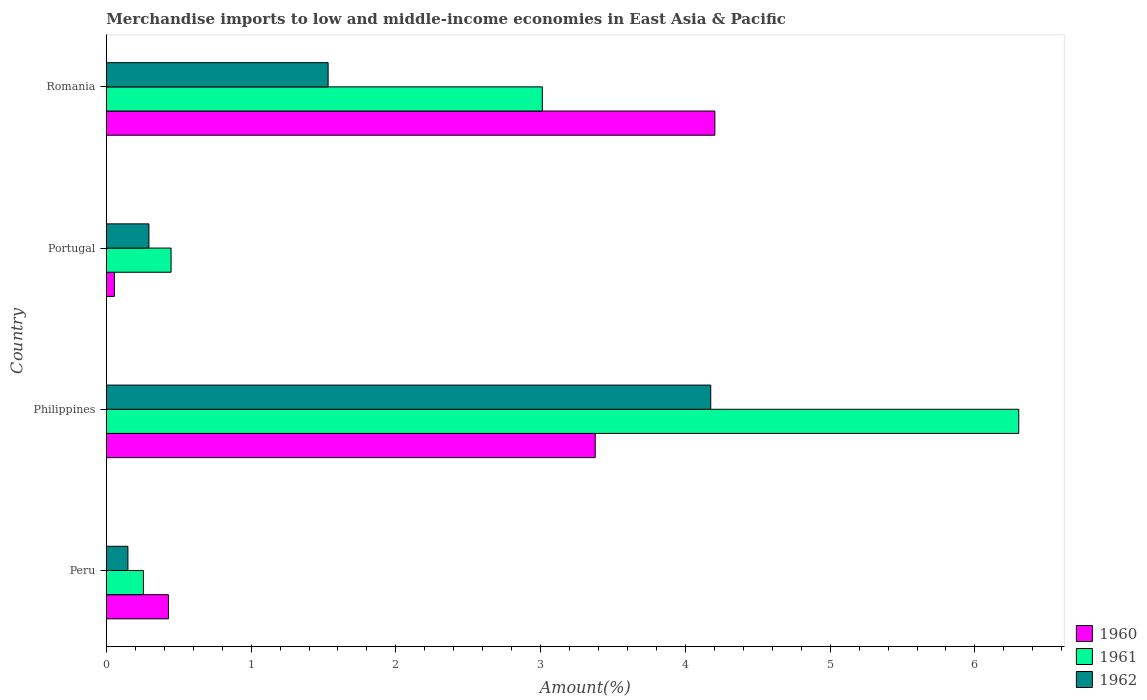Are the number of bars per tick equal to the number of legend labels?
Your response must be concise. Yes. How many bars are there on the 3rd tick from the top?
Ensure brevity in your answer.  3. What is the percentage of amount earned from merchandise imports in 1962 in Romania?
Your response must be concise. 1.53. Across all countries, what is the maximum percentage of amount earned from merchandise imports in 1962?
Provide a succinct answer. 4.18. Across all countries, what is the minimum percentage of amount earned from merchandise imports in 1960?
Your answer should be very brief. 0.06. In which country was the percentage of amount earned from merchandise imports in 1960 maximum?
Provide a short and direct response. Romania. In which country was the percentage of amount earned from merchandise imports in 1962 minimum?
Keep it short and to the point. Peru. What is the total percentage of amount earned from merchandise imports in 1960 in the graph?
Make the answer very short. 8.07. What is the difference between the percentage of amount earned from merchandise imports in 1961 in Peru and that in Romania?
Provide a succinct answer. -2.76. What is the difference between the percentage of amount earned from merchandise imports in 1960 in Peru and the percentage of amount earned from merchandise imports in 1962 in Romania?
Your answer should be compact. -1.1. What is the average percentage of amount earned from merchandise imports in 1960 per country?
Ensure brevity in your answer.  2.02. What is the difference between the percentage of amount earned from merchandise imports in 1961 and percentage of amount earned from merchandise imports in 1962 in Romania?
Offer a terse response. 1.48. In how many countries, is the percentage of amount earned from merchandise imports in 1962 greater than 2.6 %?
Provide a short and direct response. 1. What is the ratio of the percentage of amount earned from merchandise imports in 1961 in Peru to that in Portugal?
Offer a terse response. 0.57. Is the percentage of amount earned from merchandise imports in 1960 in Peru less than that in Portugal?
Your response must be concise. No. Is the difference between the percentage of amount earned from merchandise imports in 1961 in Peru and Portugal greater than the difference between the percentage of amount earned from merchandise imports in 1962 in Peru and Portugal?
Keep it short and to the point. No. What is the difference between the highest and the second highest percentage of amount earned from merchandise imports in 1960?
Ensure brevity in your answer.  0.83. What is the difference between the highest and the lowest percentage of amount earned from merchandise imports in 1960?
Keep it short and to the point. 4.15. In how many countries, is the percentage of amount earned from merchandise imports in 1961 greater than the average percentage of amount earned from merchandise imports in 1961 taken over all countries?
Provide a succinct answer. 2. Are all the bars in the graph horizontal?
Offer a very short reply. Yes. What is the difference between two consecutive major ticks on the X-axis?
Ensure brevity in your answer.  1. Are the values on the major ticks of X-axis written in scientific E-notation?
Your answer should be very brief. No. Does the graph contain any zero values?
Offer a very short reply. No. How many legend labels are there?
Your answer should be compact. 3. What is the title of the graph?
Your answer should be compact. Merchandise imports to low and middle-income economies in East Asia & Pacific. What is the label or title of the X-axis?
Your answer should be compact. Amount(%). What is the Amount(%) in 1960 in Peru?
Your response must be concise. 0.43. What is the Amount(%) of 1961 in Peru?
Give a very brief answer. 0.26. What is the Amount(%) in 1962 in Peru?
Your response must be concise. 0.15. What is the Amount(%) of 1960 in Philippines?
Your response must be concise. 3.38. What is the Amount(%) in 1961 in Philippines?
Offer a very short reply. 6.3. What is the Amount(%) in 1962 in Philippines?
Give a very brief answer. 4.18. What is the Amount(%) of 1960 in Portugal?
Keep it short and to the point. 0.06. What is the Amount(%) of 1961 in Portugal?
Provide a succinct answer. 0.45. What is the Amount(%) of 1962 in Portugal?
Your answer should be compact. 0.29. What is the Amount(%) in 1960 in Romania?
Offer a very short reply. 4.2. What is the Amount(%) in 1961 in Romania?
Offer a terse response. 3.01. What is the Amount(%) in 1962 in Romania?
Your answer should be very brief. 1.53. Across all countries, what is the maximum Amount(%) of 1960?
Your answer should be compact. 4.2. Across all countries, what is the maximum Amount(%) in 1961?
Offer a very short reply. 6.3. Across all countries, what is the maximum Amount(%) of 1962?
Make the answer very short. 4.18. Across all countries, what is the minimum Amount(%) of 1960?
Your response must be concise. 0.06. Across all countries, what is the minimum Amount(%) of 1961?
Offer a terse response. 0.26. Across all countries, what is the minimum Amount(%) in 1962?
Give a very brief answer. 0.15. What is the total Amount(%) of 1960 in the graph?
Provide a short and direct response. 8.07. What is the total Amount(%) of 1961 in the graph?
Your answer should be very brief. 10.02. What is the total Amount(%) in 1962 in the graph?
Offer a terse response. 6.15. What is the difference between the Amount(%) of 1960 in Peru and that in Philippines?
Your answer should be very brief. -2.95. What is the difference between the Amount(%) of 1961 in Peru and that in Philippines?
Your answer should be very brief. -6.05. What is the difference between the Amount(%) in 1962 in Peru and that in Philippines?
Give a very brief answer. -4.03. What is the difference between the Amount(%) in 1960 in Peru and that in Portugal?
Your response must be concise. 0.37. What is the difference between the Amount(%) in 1961 in Peru and that in Portugal?
Your answer should be compact. -0.19. What is the difference between the Amount(%) in 1962 in Peru and that in Portugal?
Provide a short and direct response. -0.14. What is the difference between the Amount(%) of 1960 in Peru and that in Romania?
Make the answer very short. -3.77. What is the difference between the Amount(%) in 1961 in Peru and that in Romania?
Your response must be concise. -2.76. What is the difference between the Amount(%) of 1962 in Peru and that in Romania?
Provide a succinct answer. -1.38. What is the difference between the Amount(%) of 1960 in Philippines and that in Portugal?
Your response must be concise. 3.32. What is the difference between the Amount(%) of 1961 in Philippines and that in Portugal?
Provide a succinct answer. 5.86. What is the difference between the Amount(%) of 1962 in Philippines and that in Portugal?
Give a very brief answer. 3.88. What is the difference between the Amount(%) in 1960 in Philippines and that in Romania?
Your answer should be very brief. -0.83. What is the difference between the Amount(%) in 1961 in Philippines and that in Romania?
Offer a very short reply. 3.29. What is the difference between the Amount(%) in 1962 in Philippines and that in Romania?
Offer a very short reply. 2.64. What is the difference between the Amount(%) in 1960 in Portugal and that in Romania?
Ensure brevity in your answer.  -4.15. What is the difference between the Amount(%) in 1961 in Portugal and that in Romania?
Give a very brief answer. -2.56. What is the difference between the Amount(%) in 1962 in Portugal and that in Romania?
Make the answer very short. -1.24. What is the difference between the Amount(%) in 1960 in Peru and the Amount(%) in 1961 in Philippines?
Offer a terse response. -5.87. What is the difference between the Amount(%) in 1960 in Peru and the Amount(%) in 1962 in Philippines?
Make the answer very short. -3.75. What is the difference between the Amount(%) in 1961 in Peru and the Amount(%) in 1962 in Philippines?
Your answer should be very brief. -3.92. What is the difference between the Amount(%) in 1960 in Peru and the Amount(%) in 1961 in Portugal?
Offer a terse response. -0.02. What is the difference between the Amount(%) in 1960 in Peru and the Amount(%) in 1962 in Portugal?
Offer a terse response. 0.14. What is the difference between the Amount(%) in 1961 in Peru and the Amount(%) in 1962 in Portugal?
Offer a terse response. -0.04. What is the difference between the Amount(%) in 1960 in Peru and the Amount(%) in 1961 in Romania?
Your answer should be compact. -2.58. What is the difference between the Amount(%) in 1960 in Peru and the Amount(%) in 1962 in Romania?
Your answer should be very brief. -1.1. What is the difference between the Amount(%) of 1961 in Peru and the Amount(%) of 1962 in Romania?
Ensure brevity in your answer.  -1.28. What is the difference between the Amount(%) of 1960 in Philippines and the Amount(%) of 1961 in Portugal?
Ensure brevity in your answer.  2.93. What is the difference between the Amount(%) in 1960 in Philippines and the Amount(%) in 1962 in Portugal?
Provide a short and direct response. 3.08. What is the difference between the Amount(%) in 1961 in Philippines and the Amount(%) in 1962 in Portugal?
Offer a very short reply. 6.01. What is the difference between the Amount(%) in 1960 in Philippines and the Amount(%) in 1961 in Romania?
Provide a short and direct response. 0.37. What is the difference between the Amount(%) in 1960 in Philippines and the Amount(%) in 1962 in Romania?
Keep it short and to the point. 1.85. What is the difference between the Amount(%) in 1961 in Philippines and the Amount(%) in 1962 in Romania?
Provide a short and direct response. 4.77. What is the difference between the Amount(%) of 1960 in Portugal and the Amount(%) of 1961 in Romania?
Offer a terse response. -2.96. What is the difference between the Amount(%) of 1960 in Portugal and the Amount(%) of 1962 in Romania?
Provide a succinct answer. -1.48. What is the difference between the Amount(%) in 1961 in Portugal and the Amount(%) in 1962 in Romania?
Offer a terse response. -1.08. What is the average Amount(%) of 1960 per country?
Give a very brief answer. 2.02. What is the average Amount(%) in 1961 per country?
Give a very brief answer. 2.5. What is the average Amount(%) of 1962 per country?
Your answer should be very brief. 1.54. What is the difference between the Amount(%) of 1960 and Amount(%) of 1961 in Peru?
Provide a succinct answer. 0.17. What is the difference between the Amount(%) in 1960 and Amount(%) in 1962 in Peru?
Make the answer very short. 0.28. What is the difference between the Amount(%) in 1961 and Amount(%) in 1962 in Peru?
Keep it short and to the point. 0.11. What is the difference between the Amount(%) of 1960 and Amount(%) of 1961 in Philippines?
Offer a very short reply. -2.93. What is the difference between the Amount(%) of 1960 and Amount(%) of 1962 in Philippines?
Offer a very short reply. -0.8. What is the difference between the Amount(%) of 1961 and Amount(%) of 1962 in Philippines?
Your answer should be very brief. 2.13. What is the difference between the Amount(%) in 1960 and Amount(%) in 1961 in Portugal?
Provide a short and direct response. -0.39. What is the difference between the Amount(%) of 1960 and Amount(%) of 1962 in Portugal?
Provide a succinct answer. -0.24. What is the difference between the Amount(%) of 1961 and Amount(%) of 1962 in Portugal?
Your answer should be compact. 0.15. What is the difference between the Amount(%) in 1960 and Amount(%) in 1961 in Romania?
Provide a succinct answer. 1.19. What is the difference between the Amount(%) of 1960 and Amount(%) of 1962 in Romania?
Provide a succinct answer. 2.67. What is the difference between the Amount(%) of 1961 and Amount(%) of 1962 in Romania?
Offer a terse response. 1.48. What is the ratio of the Amount(%) in 1960 in Peru to that in Philippines?
Provide a short and direct response. 0.13. What is the ratio of the Amount(%) in 1961 in Peru to that in Philippines?
Your answer should be very brief. 0.04. What is the ratio of the Amount(%) of 1962 in Peru to that in Philippines?
Provide a short and direct response. 0.04. What is the ratio of the Amount(%) of 1960 in Peru to that in Portugal?
Give a very brief answer. 7.71. What is the ratio of the Amount(%) of 1961 in Peru to that in Portugal?
Ensure brevity in your answer.  0.57. What is the ratio of the Amount(%) of 1962 in Peru to that in Portugal?
Your answer should be very brief. 0.51. What is the ratio of the Amount(%) of 1960 in Peru to that in Romania?
Offer a terse response. 0.1. What is the ratio of the Amount(%) in 1961 in Peru to that in Romania?
Ensure brevity in your answer.  0.09. What is the ratio of the Amount(%) of 1962 in Peru to that in Romania?
Ensure brevity in your answer.  0.1. What is the ratio of the Amount(%) in 1960 in Philippines to that in Portugal?
Provide a succinct answer. 60.74. What is the ratio of the Amount(%) in 1961 in Philippines to that in Portugal?
Offer a very short reply. 14.09. What is the ratio of the Amount(%) in 1962 in Philippines to that in Portugal?
Give a very brief answer. 14.2. What is the ratio of the Amount(%) of 1960 in Philippines to that in Romania?
Make the answer very short. 0.8. What is the ratio of the Amount(%) in 1961 in Philippines to that in Romania?
Make the answer very short. 2.09. What is the ratio of the Amount(%) in 1962 in Philippines to that in Romania?
Provide a short and direct response. 2.73. What is the ratio of the Amount(%) of 1960 in Portugal to that in Romania?
Give a very brief answer. 0.01. What is the ratio of the Amount(%) of 1961 in Portugal to that in Romania?
Offer a very short reply. 0.15. What is the ratio of the Amount(%) of 1962 in Portugal to that in Romania?
Offer a very short reply. 0.19. What is the difference between the highest and the second highest Amount(%) in 1960?
Your response must be concise. 0.83. What is the difference between the highest and the second highest Amount(%) of 1961?
Provide a succinct answer. 3.29. What is the difference between the highest and the second highest Amount(%) of 1962?
Offer a terse response. 2.64. What is the difference between the highest and the lowest Amount(%) in 1960?
Ensure brevity in your answer.  4.15. What is the difference between the highest and the lowest Amount(%) of 1961?
Ensure brevity in your answer.  6.05. What is the difference between the highest and the lowest Amount(%) in 1962?
Your answer should be very brief. 4.03. 